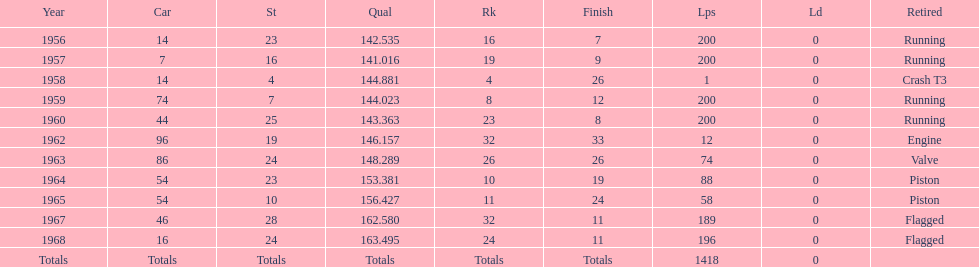On how many occasions did he finish all 200 circuits? 4. 